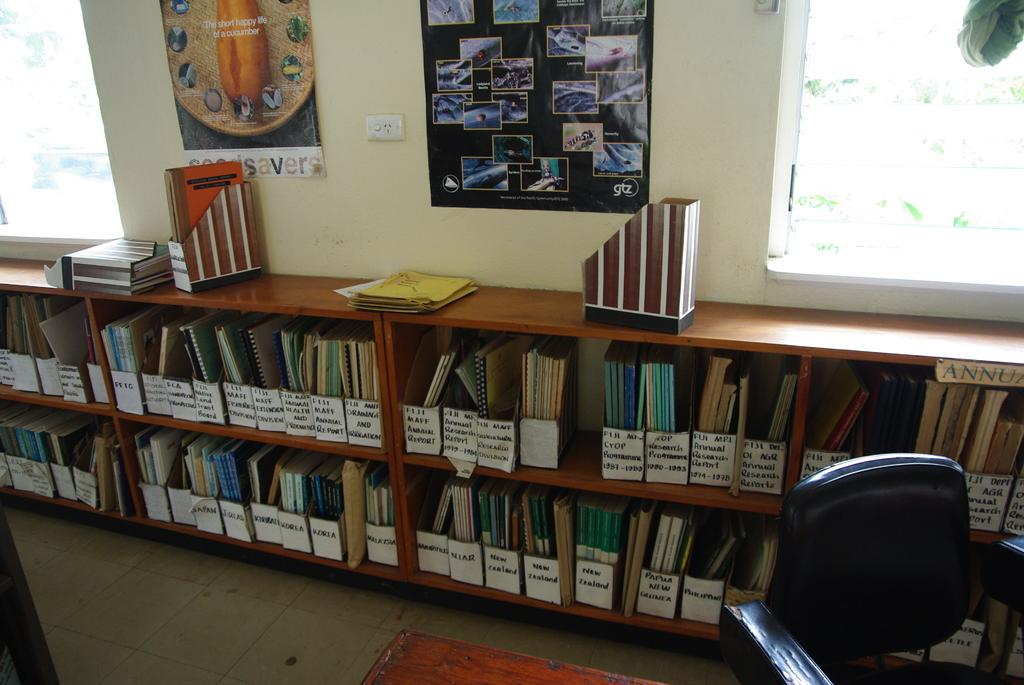Provide a one-sentence caption for the provided image. Reports labeled, annual, Korea, Japan, and others in folders on shelves in a room. 